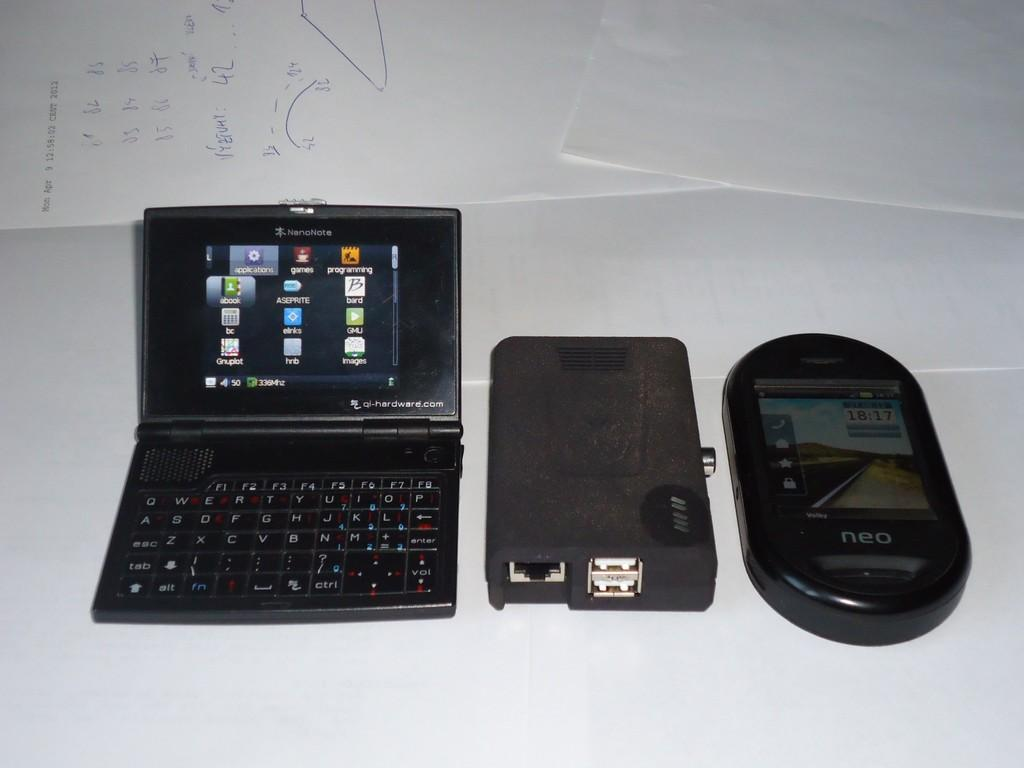<image>
Relay a brief, clear account of the picture shown. A lap top, a plug device and a small Neo phone are sitting on a table. 